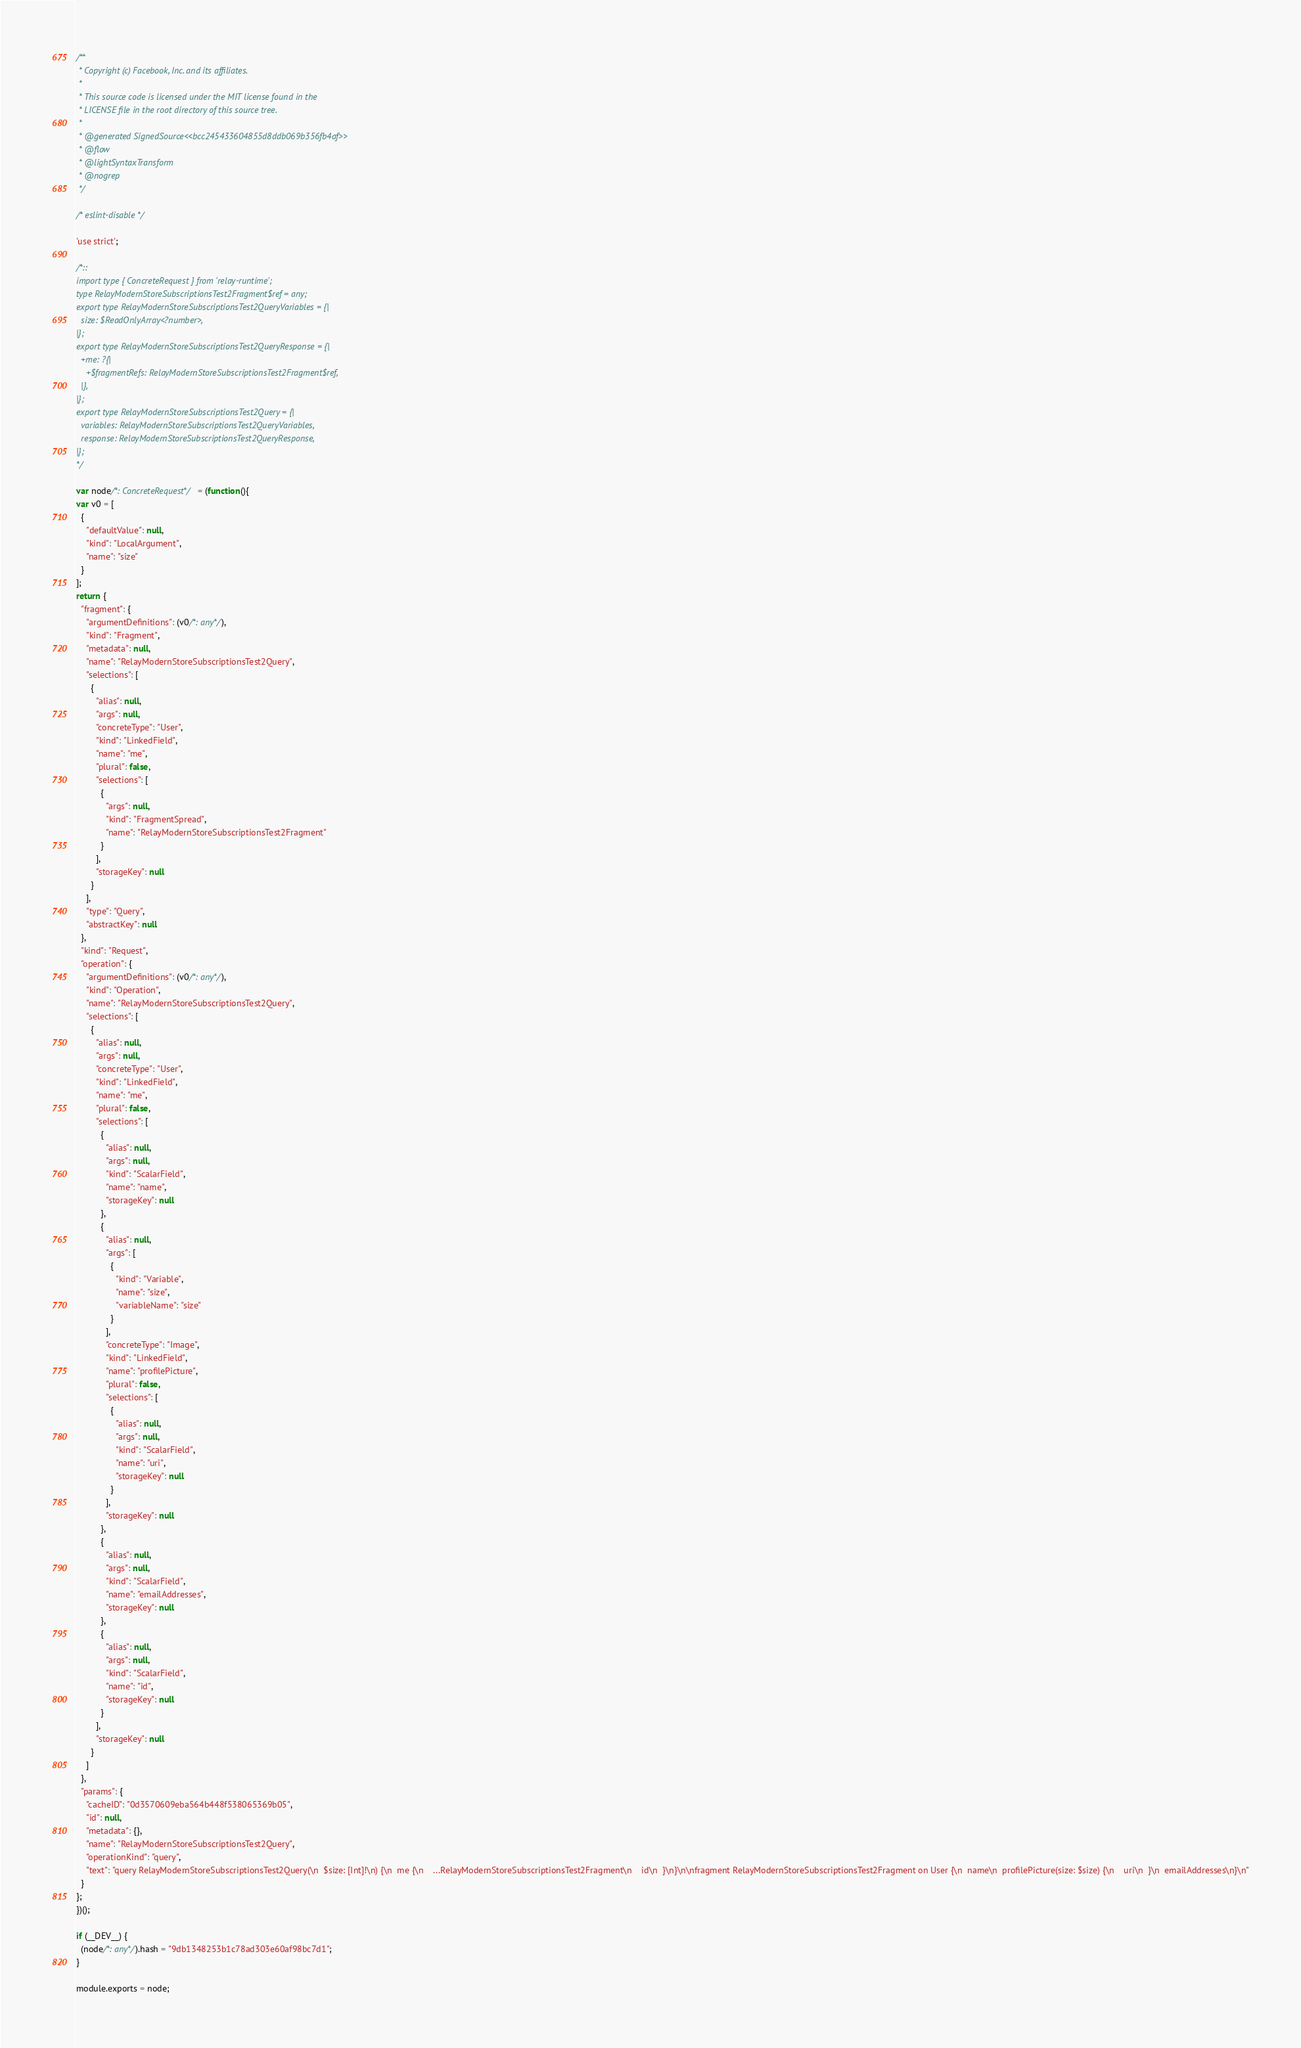Convert code to text. <code><loc_0><loc_0><loc_500><loc_500><_JavaScript_>/**
 * Copyright (c) Facebook, Inc. and its affiliates.
 * 
 * This source code is licensed under the MIT license found in the
 * LICENSE file in the root directory of this source tree.
 *
 * @generated SignedSource<<bcc245433604855d8ddb069b356fb4af>>
 * @flow
 * @lightSyntaxTransform
 * @nogrep
 */

/* eslint-disable */

'use strict';

/*::
import type { ConcreteRequest } from 'relay-runtime';
type RelayModernStoreSubscriptionsTest2Fragment$ref = any;
export type RelayModernStoreSubscriptionsTest2QueryVariables = {|
  size: $ReadOnlyArray<?number>,
|};
export type RelayModernStoreSubscriptionsTest2QueryResponse = {|
  +me: ?{|
    +$fragmentRefs: RelayModernStoreSubscriptionsTest2Fragment$ref,
  |},
|};
export type RelayModernStoreSubscriptionsTest2Query = {|
  variables: RelayModernStoreSubscriptionsTest2QueryVariables,
  response: RelayModernStoreSubscriptionsTest2QueryResponse,
|};
*/

var node/*: ConcreteRequest*/ = (function(){
var v0 = [
  {
    "defaultValue": null,
    "kind": "LocalArgument",
    "name": "size"
  }
];
return {
  "fragment": {
    "argumentDefinitions": (v0/*: any*/),
    "kind": "Fragment",
    "metadata": null,
    "name": "RelayModernStoreSubscriptionsTest2Query",
    "selections": [
      {
        "alias": null,
        "args": null,
        "concreteType": "User",
        "kind": "LinkedField",
        "name": "me",
        "plural": false,
        "selections": [
          {
            "args": null,
            "kind": "FragmentSpread",
            "name": "RelayModernStoreSubscriptionsTest2Fragment"
          }
        ],
        "storageKey": null
      }
    ],
    "type": "Query",
    "abstractKey": null
  },
  "kind": "Request",
  "operation": {
    "argumentDefinitions": (v0/*: any*/),
    "kind": "Operation",
    "name": "RelayModernStoreSubscriptionsTest2Query",
    "selections": [
      {
        "alias": null,
        "args": null,
        "concreteType": "User",
        "kind": "LinkedField",
        "name": "me",
        "plural": false,
        "selections": [
          {
            "alias": null,
            "args": null,
            "kind": "ScalarField",
            "name": "name",
            "storageKey": null
          },
          {
            "alias": null,
            "args": [
              {
                "kind": "Variable",
                "name": "size",
                "variableName": "size"
              }
            ],
            "concreteType": "Image",
            "kind": "LinkedField",
            "name": "profilePicture",
            "plural": false,
            "selections": [
              {
                "alias": null,
                "args": null,
                "kind": "ScalarField",
                "name": "uri",
                "storageKey": null
              }
            ],
            "storageKey": null
          },
          {
            "alias": null,
            "args": null,
            "kind": "ScalarField",
            "name": "emailAddresses",
            "storageKey": null
          },
          {
            "alias": null,
            "args": null,
            "kind": "ScalarField",
            "name": "id",
            "storageKey": null
          }
        ],
        "storageKey": null
      }
    ]
  },
  "params": {
    "cacheID": "0d3570609eba564b448f538065369b05",
    "id": null,
    "metadata": {},
    "name": "RelayModernStoreSubscriptionsTest2Query",
    "operationKind": "query",
    "text": "query RelayModernStoreSubscriptionsTest2Query(\n  $size: [Int]!\n) {\n  me {\n    ...RelayModernStoreSubscriptionsTest2Fragment\n    id\n  }\n}\n\nfragment RelayModernStoreSubscriptionsTest2Fragment on User {\n  name\n  profilePicture(size: $size) {\n    uri\n  }\n  emailAddresses\n}\n"
  }
};
})();

if (__DEV__) {
  (node/*: any*/).hash = "9db1348253b1c78ad303e60af98bc7d1";
}

module.exports = node;
</code> 